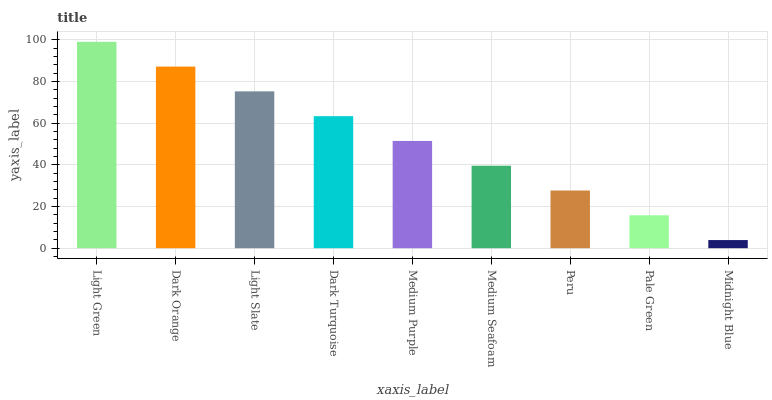Is Midnight Blue the minimum?
Answer yes or no. Yes. Is Light Green the maximum?
Answer yes or no. Yes. Is Dark Orange the minimum?
Answer yes or no. No. Is Dark Orange the maximum?
Answer yes or no. No. Is Light Green greater than Dark Orange?
Answer yes or no. Yes. Is Dark Orange less than Light Green?
Answer yes or no. Yes. Is Dark Orange greater than Light Green?
Answer yes or no. No. Is Light Green less than Dark Orange?
Answer yes or no. No. Is Medium Purple the high median?
Answer yes or no. Yes. Is Medium Purple the low median?
Answer yes or no. Yes. Is Medium Seafoam the high median?
Answer yes or no. No. Is Light Slate the low median?
Answer yes or no. No. 